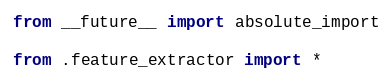Convert code to text. <code><loc_0><loc_0><loc_500><loc_500><_Python_>from __future__ import absolute_import

from .feature_extractor import *</code> 